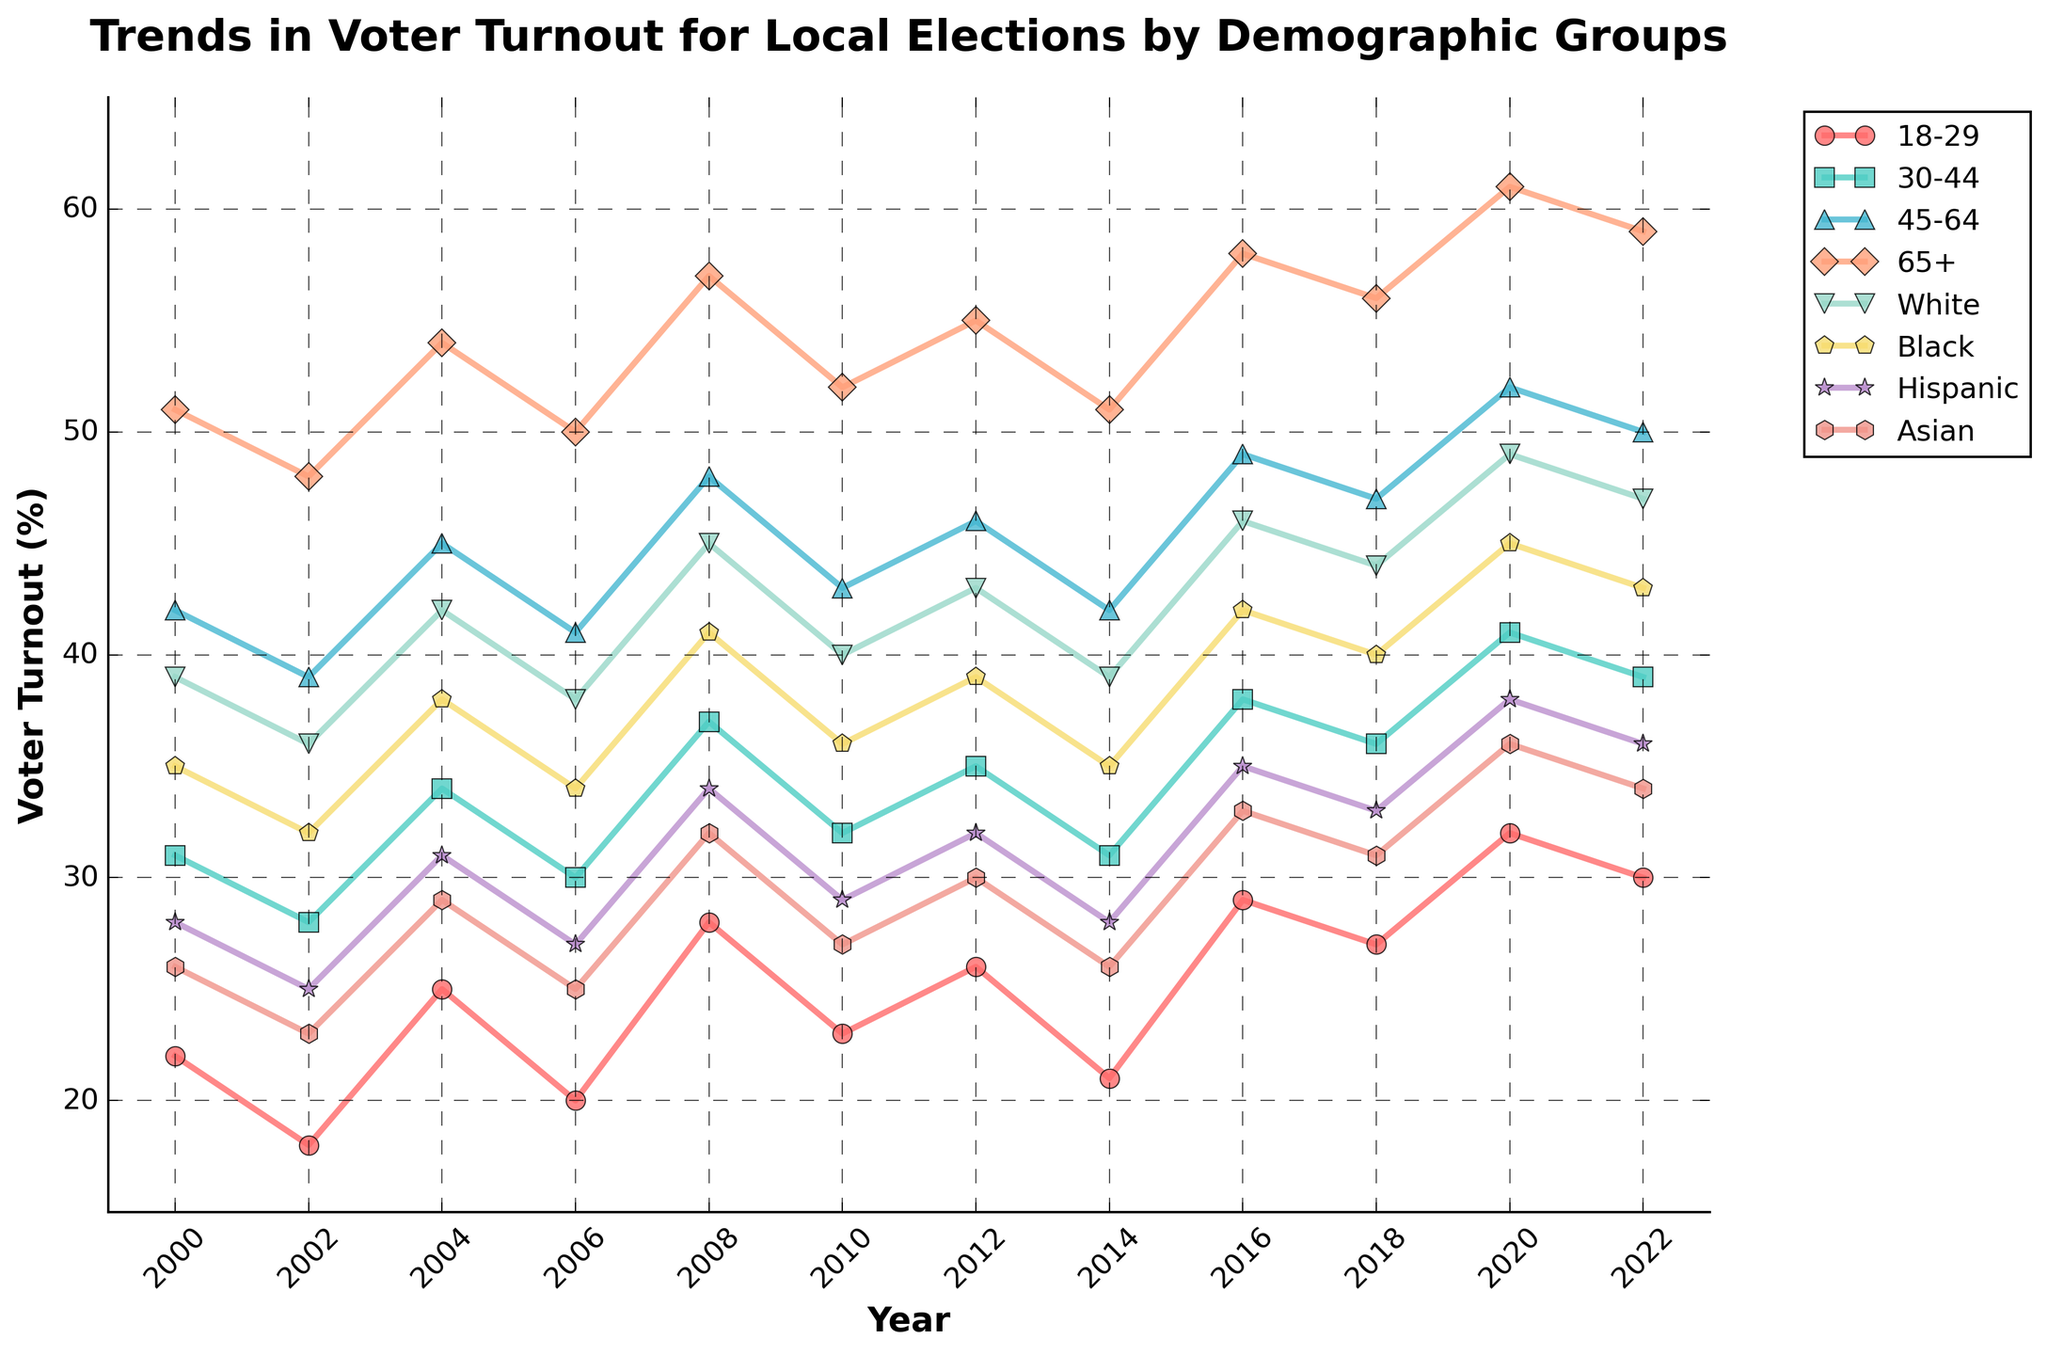What is the overall trend in voter turnout for the 18-29 age group from 2000 to 2022? The voter turnout for the 18-29 age group shows an increase from 22% in 2000 to a peak of 32% in 2020, before slightly decreasing to 30% in 2022. This indicates a general upward trend over the 22-year period.
Answer: Upward trend Which demographic had the highest voter turnout in 2022? In 2022, the demographic group with the highest voter turnout is the age group 65+, with a voter turnout of 59%.
Answer: 65+ Between 2000 and 2022, which year saw the greatest increase in voter turnout for the Black demographic? The greatest increase in voter turnout for the Black demographic occurred between 2006 and 2008, where it increased from 34% to 41%, an increase of 7 percentage points.
Answer: 2006-2008 Compare the voter turnout for White and Hispanic demographics in the year 2018. Which demographic had a higher turnout and by how much? In 2018, the voter turnout for the White demographic was 44%, while for the Hispanic demographic it was 33%. The White demographic had a higher turnout by 11 percentage points.
Answer: White, 11% How did the voter turnout for the 30-44 age group change between 2000 and 2010? In 2000, the voter turnout for the 30-44 age group was 31%. By 2010, it had increased to 32%. This indicates a slight increase of 1 percentage point over the 10-year period.
Answer: Increased, 1% What was the average voter turnout across all demographic groups in 2020? To calculate the average voter turnout across all demographic groups in 2020, sum the turnouts and divide by the number of groups. (32% + 41% + 52% + 61% + 49% + 45% + 38% + 36%) / 8 = 44.3%.
Answer: 44.3% Which age group had the most consistent voter turnout between 2000 and 2022 in terms of having the lowest range of values? The 45-64 age group had the turnout values ranging from 41% to 52%, with a range of 11 percentage points, indicating it is the most consistent.
Answer: 45-64 What is the difference in voter turnout between the White and Asian demographics in 2020? In 2020, the voter turnout for the White demographic was 49% and for the Asian demographic it was 36%. The difference is 49% - 36% = 13 percentage points.
Answer: 13% How did the voter turnout for the Hispanic demographic change between 2006 and 2020? Voter turnout for the Hispanic demographic increased from 27% in 2006 to 38% in 2020, indicating an increase of 11 percentage points over this period.
Answer: Increased, 11% Considering all demographic groups, which year had the lowest average voter turnout? Calculate the average voter turnout for each year and compare. The lowest average voter turnout across all demographic groups was in 2002. Sum of percentages for 2002 is (18+28+39+48+36+32+25+23) / 8 = 31.1%.
Answer: 2002 